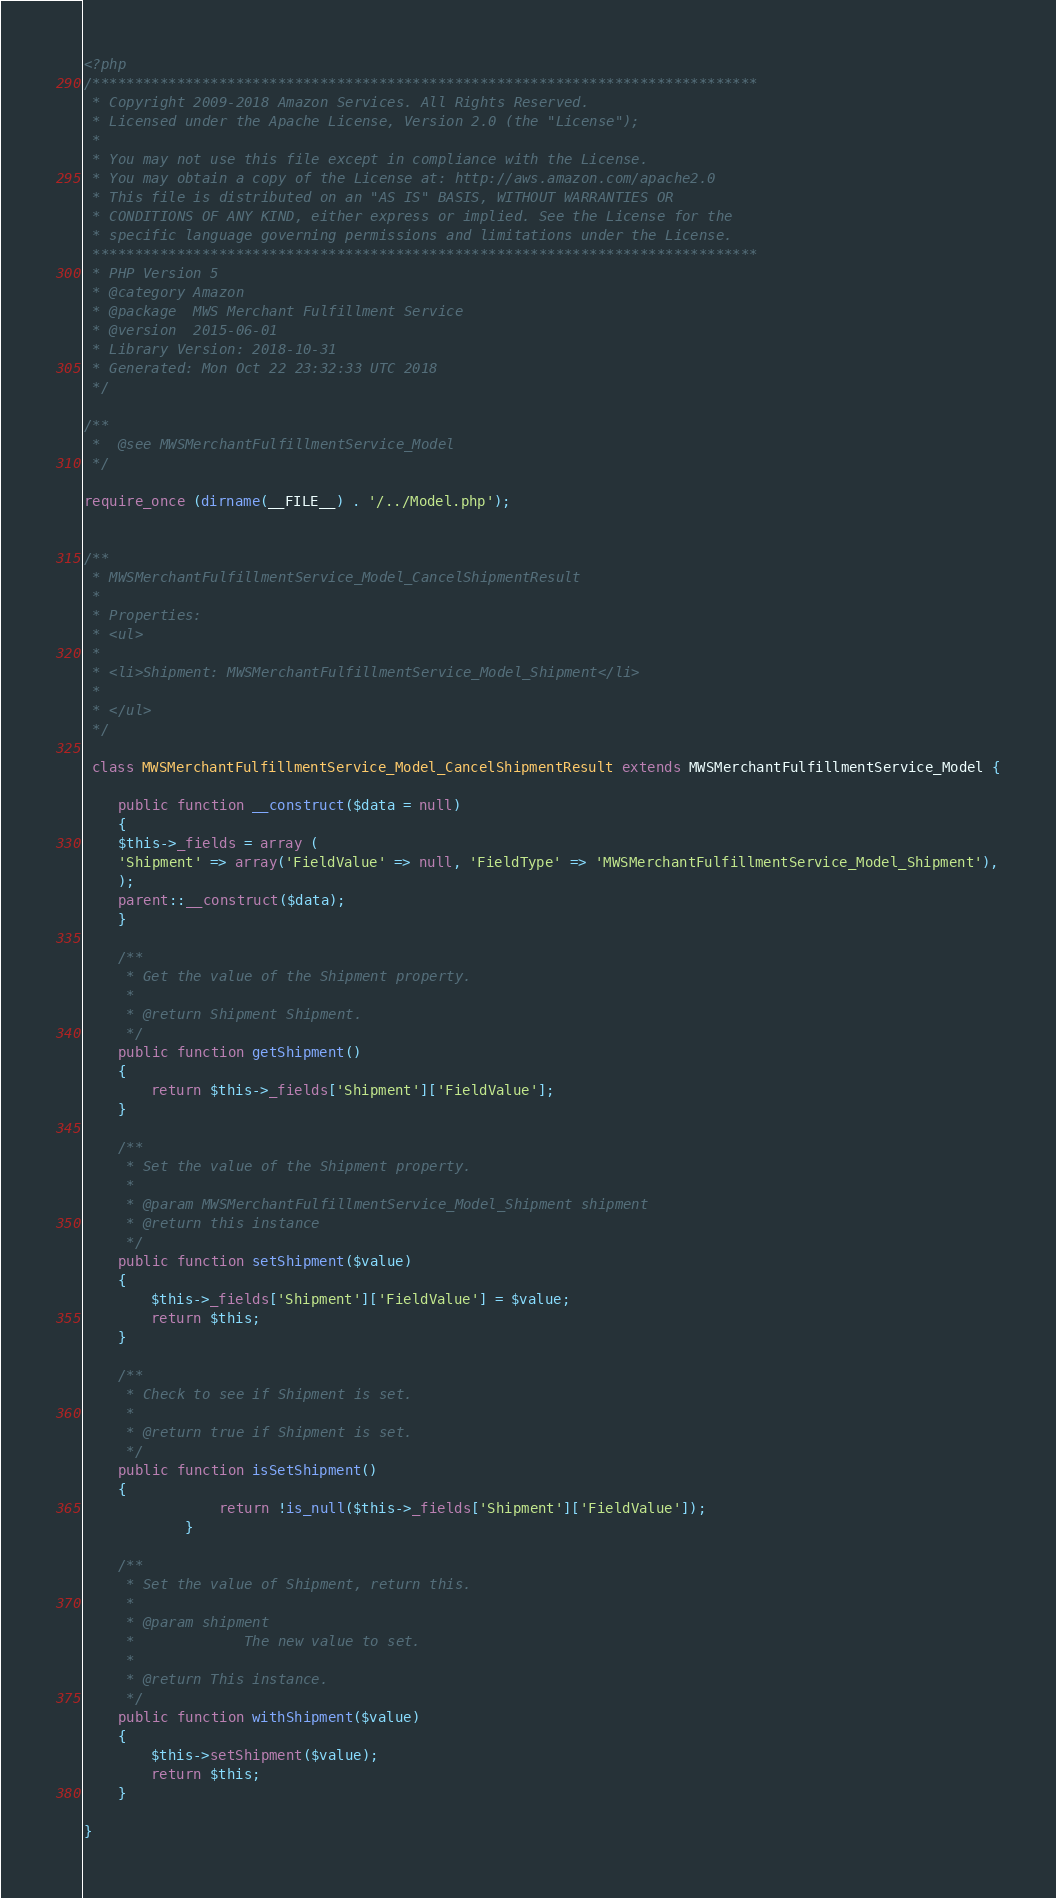Convert code to text. <code><loc_0><loc_0><loc_500><loc_500><_PHP_><?php
/*******************************************************************************
 * Copyright 2009-2018 Amazon Services. All Rights Reserved.
 * Licensed under the Apache License, Version 2.0 (the "License"); 
 *
 * You may not use this file except in compliance with the License. 
 * You may obtain a copy of the License at: http://aws.amazon.com/apache2.0
 * This file is distributed on an "AS IS" BASIS, WITHOUT WARRANTIES OR 
 * CONDITIONS OF ANY KIND, either express or implied. See the License for the 
 * specific language governing permissions and limitations under the License.
 *******************************************************************************
 * PHP Version 5
 * @category Amazon
 * @package  MWS Merchant Fulfillment Service
 * @version  2015-06-01
 * Library Version: 2018-10-31
 * Generated: Mon Oct 22 23:32:33 UTC 2018
 */

/**
 *  @see MWSMerchantFulfillmentService_Model
 */

require_once (dirname(__FILE__) . '/../Model.php');


/**
 * MWSMerchantFulfillmentService_Model_CancelShipmentResult
 * 
 * Properties:
 * <ul>
 * 
 * <li>Shipment: MWSMerchantFulfillmentService_Model_Shipment</li>
 *
 * </ul>
 */

 class MWSMerchantFulfillmentService_Model_CancelShipmentResult extends MWSMerchantFulfillmentService_Model {

    public function __construct($data = null)
    {
    $this->_fields = array (
    'Shipment' => array('FieldValue' => null, 'FieldType' => 'MWSMerchantFulfillmentService_Model_Shipment'),
    );
    parent::__construct($data);
    }

    /**
     * Get the value of the Shipment property.
     *
     * @return Shipment Shipment.
     */
    public function getShipment()
    {
        return $this->_fields['Shipment']['FieldValue'];
    }

    /**
     * Set the value of the Shipment property.
     *
     * @param MWSMerchantFulfillmentService_Model_Shipment shipment
     * @return this instance
     */
    public function setShipment($value)
    {
        $this->_fields['Shipment']['FieldValue'] = $value;
        return $this;
    }

    /**
     * Check to see if Shipment is set.
     *
     * @return true if Shipment is set.
     */
    public function isSetShipment()
    {
                return !is_null($this->_fields['Shipment']['FieldValue']);
            }

    /**
     * Set the value of Shipment, return this.
     *
     * @param shipment
     *             The new value to set.
     *
     * @return This instance.
     */
    public function withShipment($value)
    {
        $this->setShipment($value);
        return $this;
    }

}
</code> 